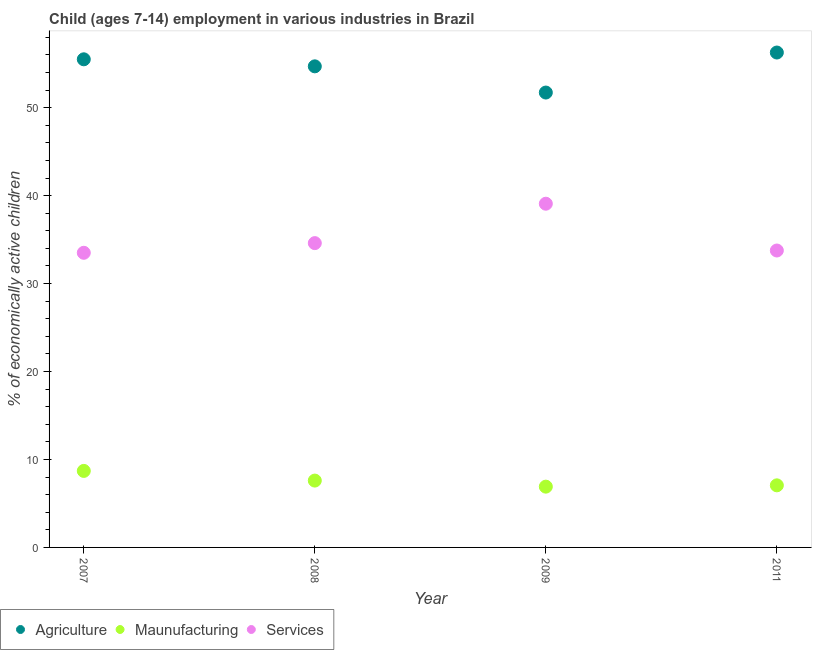How many different coloured dotlines are there?
Offer a terse response. 3. Is the number of dotlines equal to the number of legend labels?
Offer a very short reply. Yes. What is the percentage of economically active children in agriculture in 2007?
Offer a very short reply. 55.5. Across all years, what is the maximum percentage of economically active children in services?
Offer a very short reply. 39.08. Across all years, what is the minimum percentage of economically active children in manufacturing?
Keep it short and to the point. 6.91. In which year was the percentage of economically active children in services minimum?
Offer a very short reply. 2007. What is the total percentage of economically active children in manufacturing in the graph?
Provide a short and direct response. 30.27. What is the difference between the percentage of economically active children in services in 2008 and that in 2009?
Ensure brevity in your answer.  -4.48. What is the difference between the percentage of economically active children in manufacturing in 2011 and the percentage of economically active children in agriculture in 2008?
Offer a very short reply. -47.64. What is the average percentage of economically active children in agriculture per year?
Ensure brevity in your answer.  54.55. In the year 2009, what is the difference between the percentage of economically active children in services and percentage of economically active children in manufacturing?
Make the answer very short. 32.17. In how many years, is the percentage of economically active children in services greater than 36 %?
Your answer should be very brief. 1. What is the ratio of the percentage of economically active children in agriculture in 2008 to that in 2009?
Offer a very short reply. 1.06. What is the difference between the highest and the second highest percentage of economically active children in manufacturing?
Make the answer very short. 1.1. What is the difference between the highest and the lowest percentage of economically active children in agriculture?
Your answer should be compact. 4.55. Is the sum of the percentage of economically active children in services in 2007 and 2011 greater than the maximum percentage of economically active children in agriculture across all years?
Offer a terse response. Yes. Is it the case that in every year, the sum of the percentage of economically active children in agriculture and percentage of economically active children in manufacturing is greater than the percentage of economically active children in services?
Keep it short and to the point. Yes. How many years are there in the graph?
Make the answer very short. 4. What is the difference between two consecutive major ticks on the Y-axis?
Make the answer very short. 10. Does the graph contain grids?
Provide a short and direct response. No. Where does the legend appear in the graph?
Your answer should be compact. Bottom left. How many legend labels are there?
Your answer should be compact. 3. How are the legend labels stacked?
Make the answer very short. Horizontal. What is the title of the graph?
Ensure brevity in your answer.  Child (ages 7-14) employment in various industries in Brazil. What is the label or title of the Y-axis?
Keep it short and to the point. % of economically active children. What is the % of economically active children of Agriculture in 2007?
Offer a very short reply. 55.5. What is the % of economically active children in Services in 2007?
Offer a terse response. 33.5. What is the % of economically active children in Agriculture in 2008?
Give a very brief answer. 54.7. What is the % of economically active children of Services in 2008?
Your answer should be very brief. 34.6. What is the % of economically active children of Agriculture in 2009?
Your answer should be compact. 51.72. What is the % of economically active children in Maunufacturing in 2009?
Your answer should be very brief. 6.91. What is the % of economically active children of Services in 2009?
Provide a succinct answer. 39.08. What is the % of economically active children in Agriculture in 2011?
Your response must be concise. 56.27. What is the % of economically active children in Maunufacturing in 2011?
Your answer should be compact. 7.06. What is the % of economically active children of Services in 2011?
Keep it short and to the point. 33.76. Across all years, what is the maximum % of economically active children in Agriculture?
Provide a short and direct response. 56.27. Across all years, what is the maximum % of economically active children in Services?
Provide a succinct answer. 39.08. Across all years, what is the minimum % of economically active children of Agriculture?
Provide a short and direct response. 51.72. Across all years, what is the minimum % of economically active children of Maunufacturing?
Give a very brief answer. 6.91. Across all years, what is the minimum % of economically active children in Services?
Your answer should be very brief. 33.5. What is the total % of economically active children of Agriculture in the graph?
Keep it short and to the point. 218.19. What is the total % of economically active children in Maunufacturing in the graph?
Keep it short and to the point. 30.27. What is the total % of economically active children in Services in the graph?
Provide a short and direct response. 140.94. What is the difference between the % of economically active children of Agriculture in 2007 and that in 2009?
Your response must be concise. 3.78. What is the difference between the % of economically active children in Maunufacturing in 2007 and that in 2009?
Offer a very short reply. 1.79. What is the difference between the % of economically active children of Services in 2007 and that in 2009?
Provide a short and direct response. -5.58. What is the difference between the % of economically active children of Agriculture in 2007 and that in 2011?
Offer a very short reply. -0.77. What is the difference between the % of economically active children in Maunufacturing in 2007 and that in 2011?
Your answer should be very brief. 1.64. What is the difference between the % of economically active children of Services in 2007 and that in 2011?
Provide a short and direct response. -0.26. What is the difference between the % of economically active children of Agriculture in 2008 and that in 2009?
Ensure brevity in your answer.  2.98. What is the difference between the % of economically active children of Maunufacturing in 2008 and that in 2009?
Offer a very short reply. 0.69. What is the difference between the % of economically active children in Services in 2008 and that in 2009?
Your answer should be very brief. -4.48. What is the difference between the % of economically active children of Agriculture in 2008 and that in 2011?
Offer a terse response. -1.57. What is the difference between the % of economically active children in Maunufacturing in 2008 and that in 2011?
Provide a short and direct response. 0.54. What is the difference between the % of economically active children of Services in 2008 and that in 2011?
Provide a short and direct response. 0.84. What is the difference between the % of economically active children in Agriculture in 2009 and that in 2011?
Give a very brief answer. -4.55. What is the difference between the % of economically active children in Maunufacturing in 2009 and that in 2011?
Make the answer very short. -0.15. What is the difference between the % of economically active children in Services in 2009 and that in 2011?
Provide a succinct answer. 5.32. What is the difference between the % of economically active children of Agriculture in 2007 and the % of economically active children of Maunufacturing in 2008?
Keep it short and to the point. 47.9. What is the difference between the % of economically active children in Agriculture in 2007 and the % of economically active children in Services in 2008?
Offer a very short reply. 20.9. What is the difference between the % of economically active children of Maunufacturing in 2007 and the % of economically active children of Services in 2008?
Provide a succinct answer. -25.9. What is the difference between the % of economically active children of Agriculture in 2007 and the % of economically active children of Maunufacturing in 2009?
Offer a terse response. 48.59. What is the difference between the % of economically active children of Agriculture in 2007 and the % of economically active children of Services in 2009?
Keep it short and to the point. 16.42. What is the difference between the % of economically active children of Maunufacturing in 2007 and the % of economically active children of Services in 2009?
Your answer should be very brief. -30.38. What is the difference between the % of economically active children of Agriculture in 2007 and the % of economically active children of Maunufacturing in 2011?
Your answer should be compact. 48.44. What is the difference between the % of economically active children of Agriculture in 2007 and the % of economically active children of Services in 2011?
Your answer should be compact. 21.74. What is the difference between the % of economically active children of Maunufacturing in 2007 and the % of economically active children of Services in 2011?
Your answer should be compact. -25.06. What is the difference between the % of economically active children of Agriculture in 2008 and the % of economically active children of Maunufacturing in 2009?
Provide a short and direct response. 47.79. What is the difference between the % of economically active children in Agriculture in 2008 and the % of economically active children in Services in 2009?
Offer a terse response. 15.62. What is the difference between the % of economically active children in Maunufacturing in 2008 and the % of economically active children in Services in 2009?
Keep it short and to the point. -31.48. What is the difference between the % of economically active children in Agriculture in 2008 and the % of economically active children in Maunufacturing in 2011?
Provide a succinct answer. 47.64. What is the difference between the % of economically active children in Agriculture in 2008 and the % of economically active children in Services in 2011?
Provide a succinct answer. 20.94. What is the difference between the % of economically active children in Maunufacturing in 2008 and the % of economically active children in Services in 2011?
Your answer should be very brief. -26.16. What is the difference between the % of economically active children in Agriculture in 2009 and the % of economically active children in Maunufacturing in 2011?
Offer a very short reply. 44.66. What is the difference between the % of economically active children in Agriculture in 2009 and the % of economically active children in Services in 2011?
Offer a terse response. 17.96. What is the difference between the % of economically active children of Maunufacturing in 2009 and the % of economically active children of Services in 2011?
Offer a terse response. -26.85. What is the average % of economically active children in Agriculture per year?
Ensure brevity in your answer.  54.55. What is the average % of economically active children of Maunufacturing per year?
Your answer should be very brief. 7.57. What is the average % of economically active children of Services per year?
Offer a very short reply. 35.23. In the year 2007, what is the difference between the % of economically active children of Agriculture and % of economically active children of Maunufacturing?
Make the answer very short. 46.8. In the year 2007, what is the difference between the % of economically active children in Agriculture and % of economically active children in Services?
Your answer should be compact. 22. In the year 2007, what is the difference between the % of economically active children of Maunufacturing and % of economically active children of Services?
Your response must be concise. -24.8. In the year 2008, what is the difference between the % of economically active children of Agriculture and % of economically active children of Maunufacturing?
Ensure brevity in your answer.  47.1. In the year 2008, what is the difference between the % of economically active children in Agriculture and % of economically active children in Services?
Give a very brief answer. 20.1. In the year 2009, what is the difference between the % of economically active children in Agriculture and % of economically active children in Maunufacturing?
Offer a terse response. 44.81. In the year 2009, what is the difference between the % of economically active children in Agriculture and % of economically active children in Services?
Provide a short and direct response. 12.64. In the year 2009, what is the difference between the % of economically active children of Maunufacturing and % of economically active children of Services?
Give a very brief answer. -32.17. In the year 2011, what is the difference between the % of economically active children of Agriculture and % of economically active children of Maunufacturing?
Provide a short and direct response. 49.21. In the year 2011, what is the difference between the % of economically active children in Agriculture and % of economically active children in Services?
Provide a short and direct response. 22.51. In the year 2011, what is the difference between the % of economically active children in Maunufacturing and % of economically active children in Services?
Offer a very short reply. -26.7. What is the ratio of the % of economically active children of Agriculture in 2007 to that in 2008?
Ensure brevity in your answer.  1.01. What is the ratio of the % of economically active children in Maunufacturing in 2007 to that in 2008?
Give a very brief answer. 1.14. What is the ratio of the % of economically active children in Services in 2007 to that in 2008?
Ensure brevity in your answer.  0.97. What is the ratio of the % of economically active children of Agriculture in 2007 to that in 2009?
Offer a very short reply. 1.07. What is the ratio of the % of economically active children in Maunufacturing in 2007 to that in 2009?
Ensure brevity in your answer.  1.26. What is the ratio of the % of economically active children of Services in 2007 to that in 2009?
Your response must be concise. 0.86. What is the ratio of the % of economically active children of Agriculture in 2007 to that in 2011?
Offer a very short reply. 0.99. What is the ratio of the % of economically active children of Maunufacturing in 2007 to that in 2011?
Provide a succinct answer. 1.23. What is the ratio of the % of economically active children in Services in 2007 to that in 2011?
Offer a very short reply. 0.99. What is the ratio of the % of economically active children in Agriculture in 2008 to that in 2009?
Give a very brief answer. 1.06. What is the ratio of the % of economically active children in Maunufacturing in 2008 to that in 2009?
Provide a short and direct response. 1.1. What is the ratio of the % of economically active children of Services in 2008 to that in 2009?
Offer a very short reply. 0.89. What is the ratio of the % of economically active children of Agriculture in 2008 to that in 2011?
Keep it short and to the point. 0.97. What is the ratio of the % of economically active children of Maunufacturing in 2008 to that in 2011?
Give a very brief answer. 1.08. What is the ratio of the % of economically active children in Services in 2008 to that in 2011?
Ensure brevity in your answer.  1.02. What is the ratio of the % of economically active children of Agriculture in 2009 to that in 2011?
Offer a terse response. 0.92. What is the ratio of the % of economically active children of Maunufacturing in 2009 to that in 2011?
Provide a succinct answer. 0.98. What is the ratio of the % of economically active children in Services in 2009 to that in 2011?
Provide a succinct answer. 1.16. What is the difference between the highest and the second highest % of economically active children of Agriculture?
Your answer should be very brief. 0.77. What is the difference between the highest and the second highest % of economically active children in Maunufacturing?
Provide a succinct answer. 1.1. What is the difference between the highest and the second highest % of economically active children of Services?
Your answer should be compact. 4.48. What is the difference between the highest and the lowest % of economically active children of Agriculture?
Ensure brevity in your answer.  4.55. What is the difference between the highest and the lowest % of economically active children of Maunufacturing?
Provide a short and direct response. 1.79. What is the difference between the highest and the lowest % of economically active children in Services?
Keep it short and to the point. 5.58. 